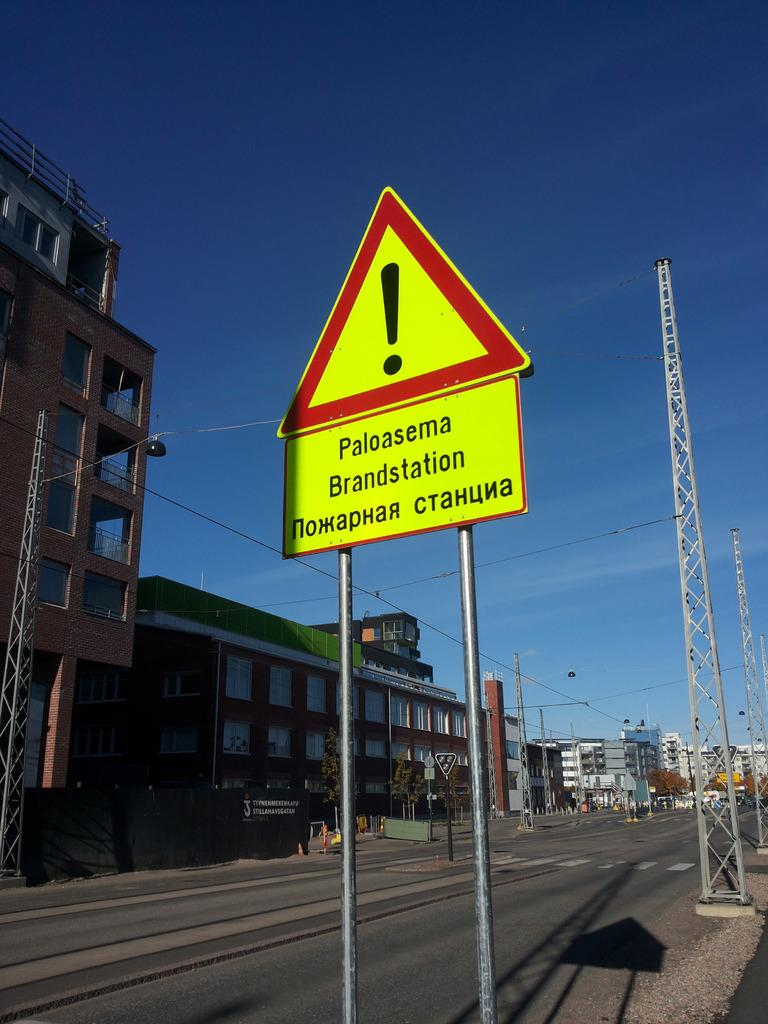<image>
Present a compact description of the photo's key features. Sign that says Paloasema brandstation on the side of the road 